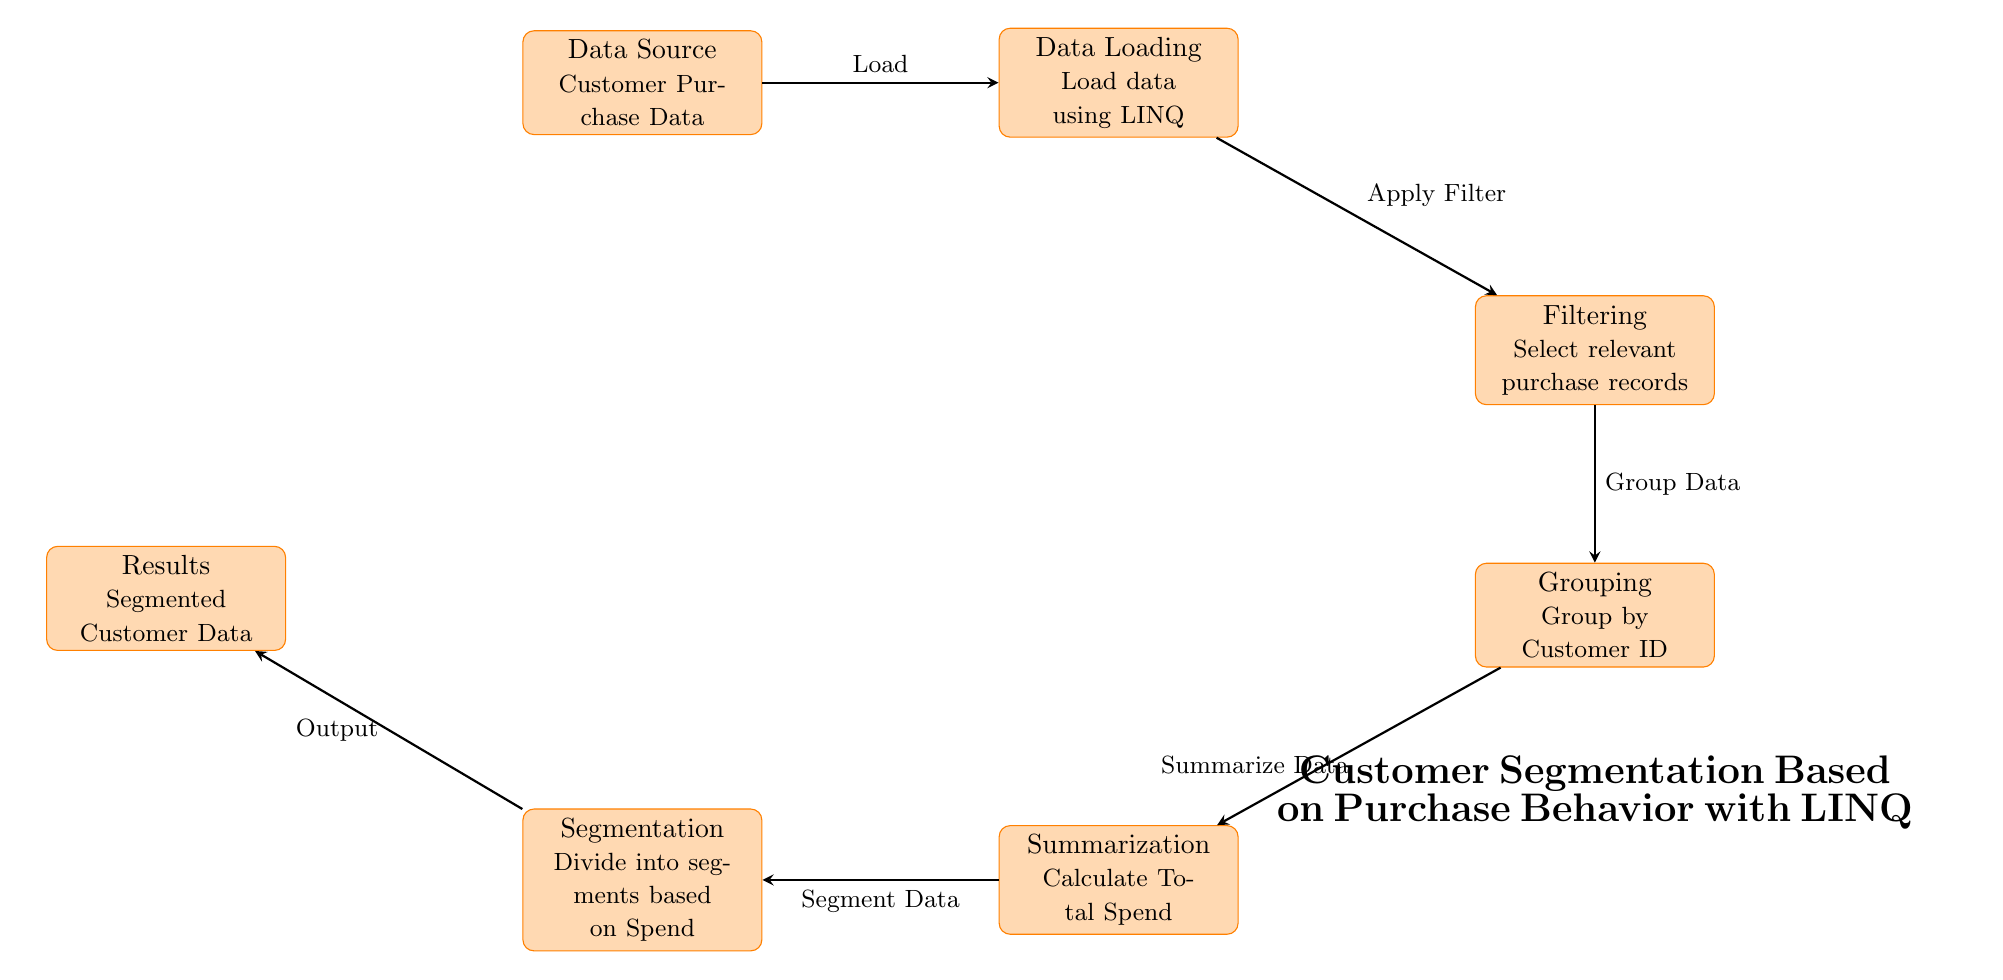What is the first process in the diagram? The first process in the diagram, as indicated at the top, is "Data Source," which refers to the input of Customer Purchase Data.
Answer: Data Source How many processes are included in the diagram? To count the processes, we look at the rectangle nodes: there are a total of six processes.
Answer: Six What type of data is loaded in the second process? The second process, labeled "Data Loading," specifies that it loads "Customer Purchase Data."
Answer: Customer Purchase Data What happens after filtering the data? After the filtering process, the diagram shows that the next step is "Grouping," which indicates that the data is grouped by customer ID.
Answer: Grouping Which process follows the "Summarization" step? According to the diagram, after the "Summarization" process, the next process is "Segmentation," where data is divided into segments based on spending.
Answer: Segmentation What is the final output of the diagram? The final output indicated in the diagram is "Segmented Customer Data," which reflects the outcome of the entire process.
Answer: Segmented Customer Data Which two processes are connected directly before the "Segmentation"? The diagram shows that the processes connected directly before "Segmentation" are "Summarization" and "Grouping." Summarization comes right before it, while Grouping is above it in the sequence.
Answer: Summarization and Grouping What does the filtering process specifically do? The filtering process in the diagram is described as selecting relevant purchase records from the loaded data, serving to narrow down the dataset for further analysis.
Answer: Select relevant purchase records What is the relationship between "Grouping" and "Summarization"? The relationship shown in the diagram indicates that "Grouping" feeds into "Summarization," meaning that after grouping the data by customer ID, the data is summarized to calculate total spend.
Answer: Grouping feeds into Summarization 